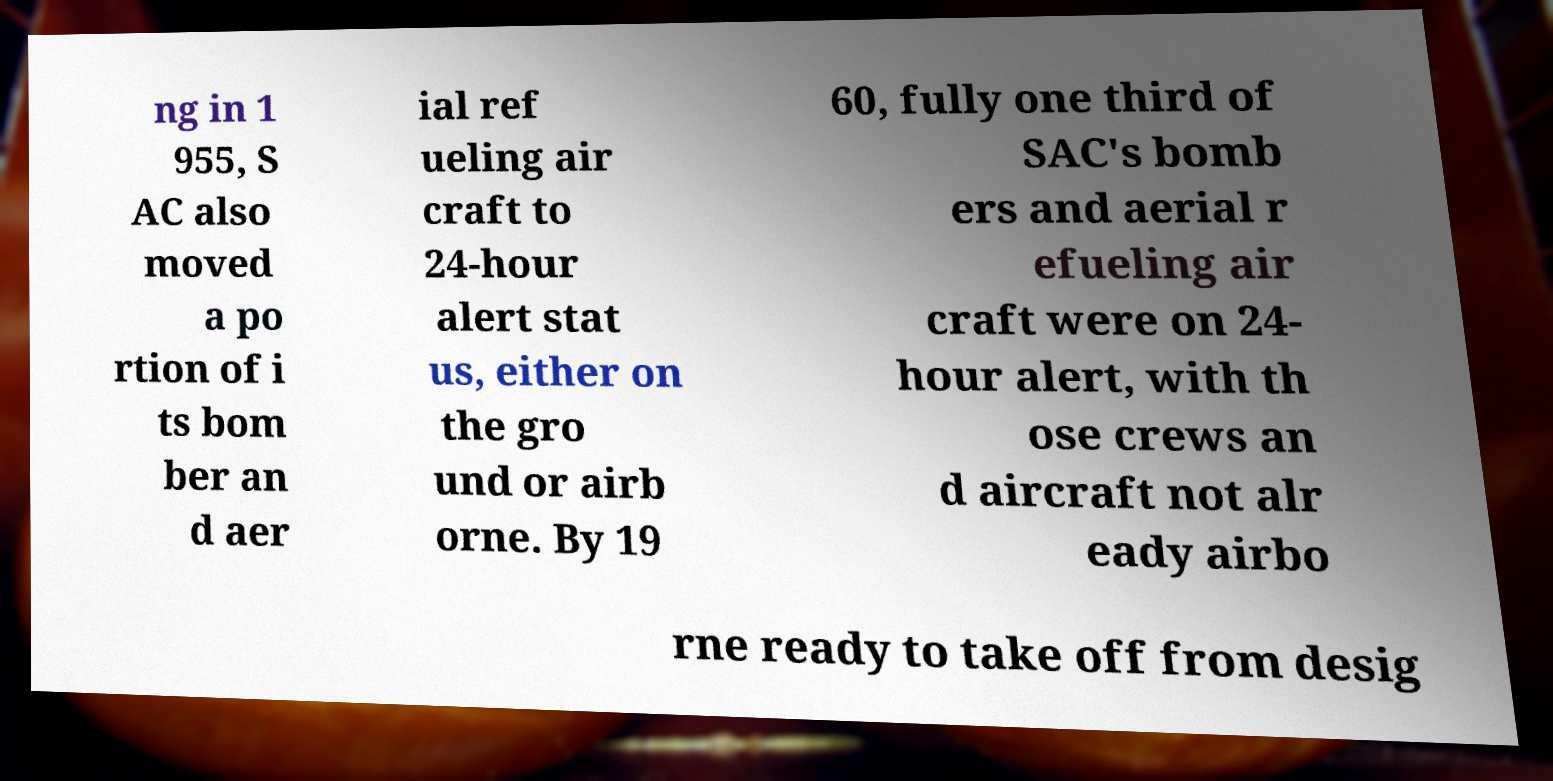Could you extract and type out the text from this image? ng in 1 955, S AC also moved a po rtion of i ts bom ber an d aer ial ref ueling air craft to 24-hour alert stat us, either on the gro und or airb orne. By 19 60, fully one third of SAC's bomb ers and aerial r efueling air craft were on 24- hour alert, with th ose crews an d aircraft not alr eady airbo rne ready to take off from desig 